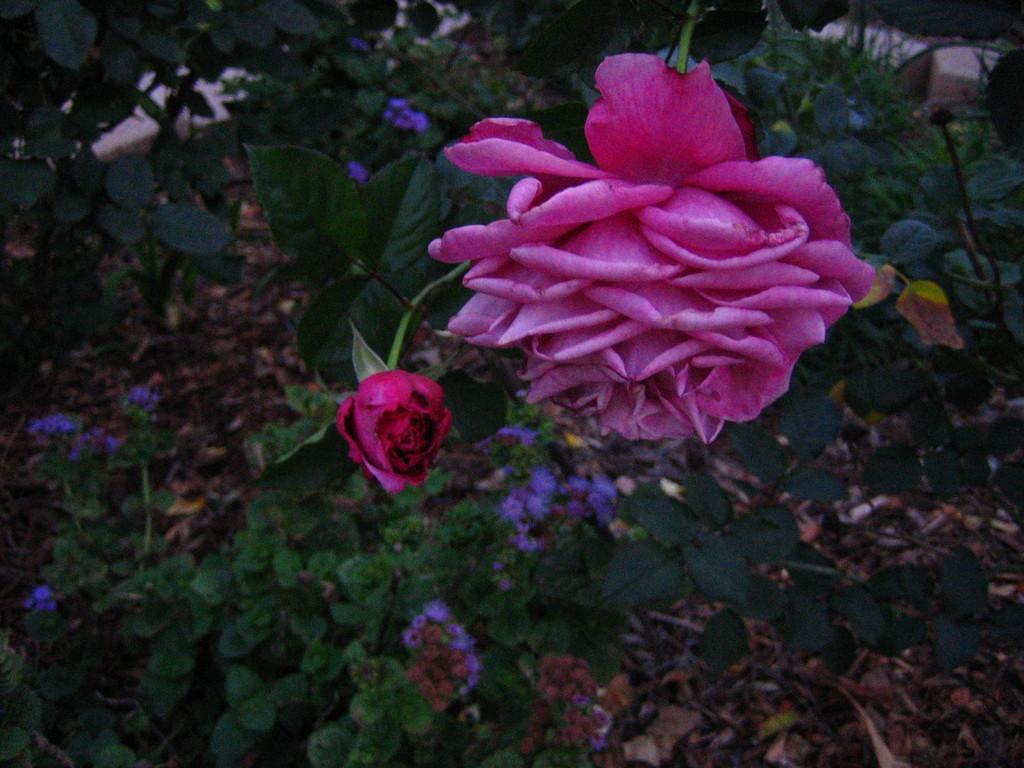How would you summarize this image in a sentence or two? In this image there are flower plants. 